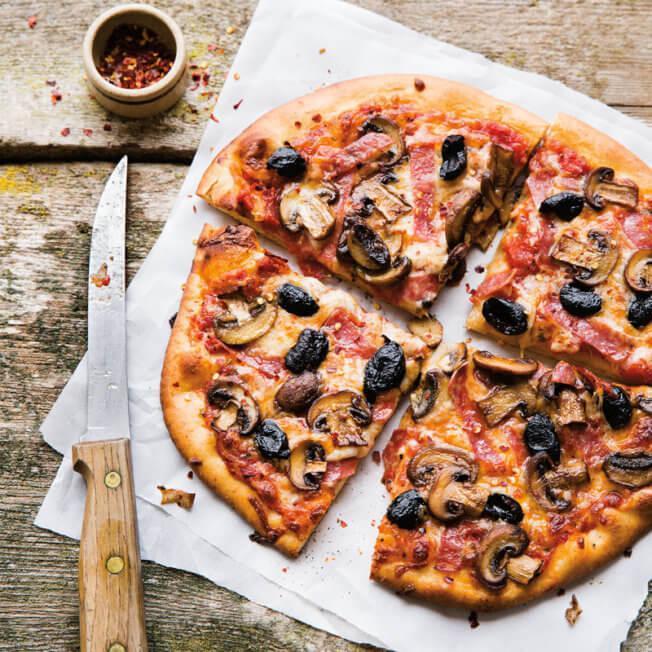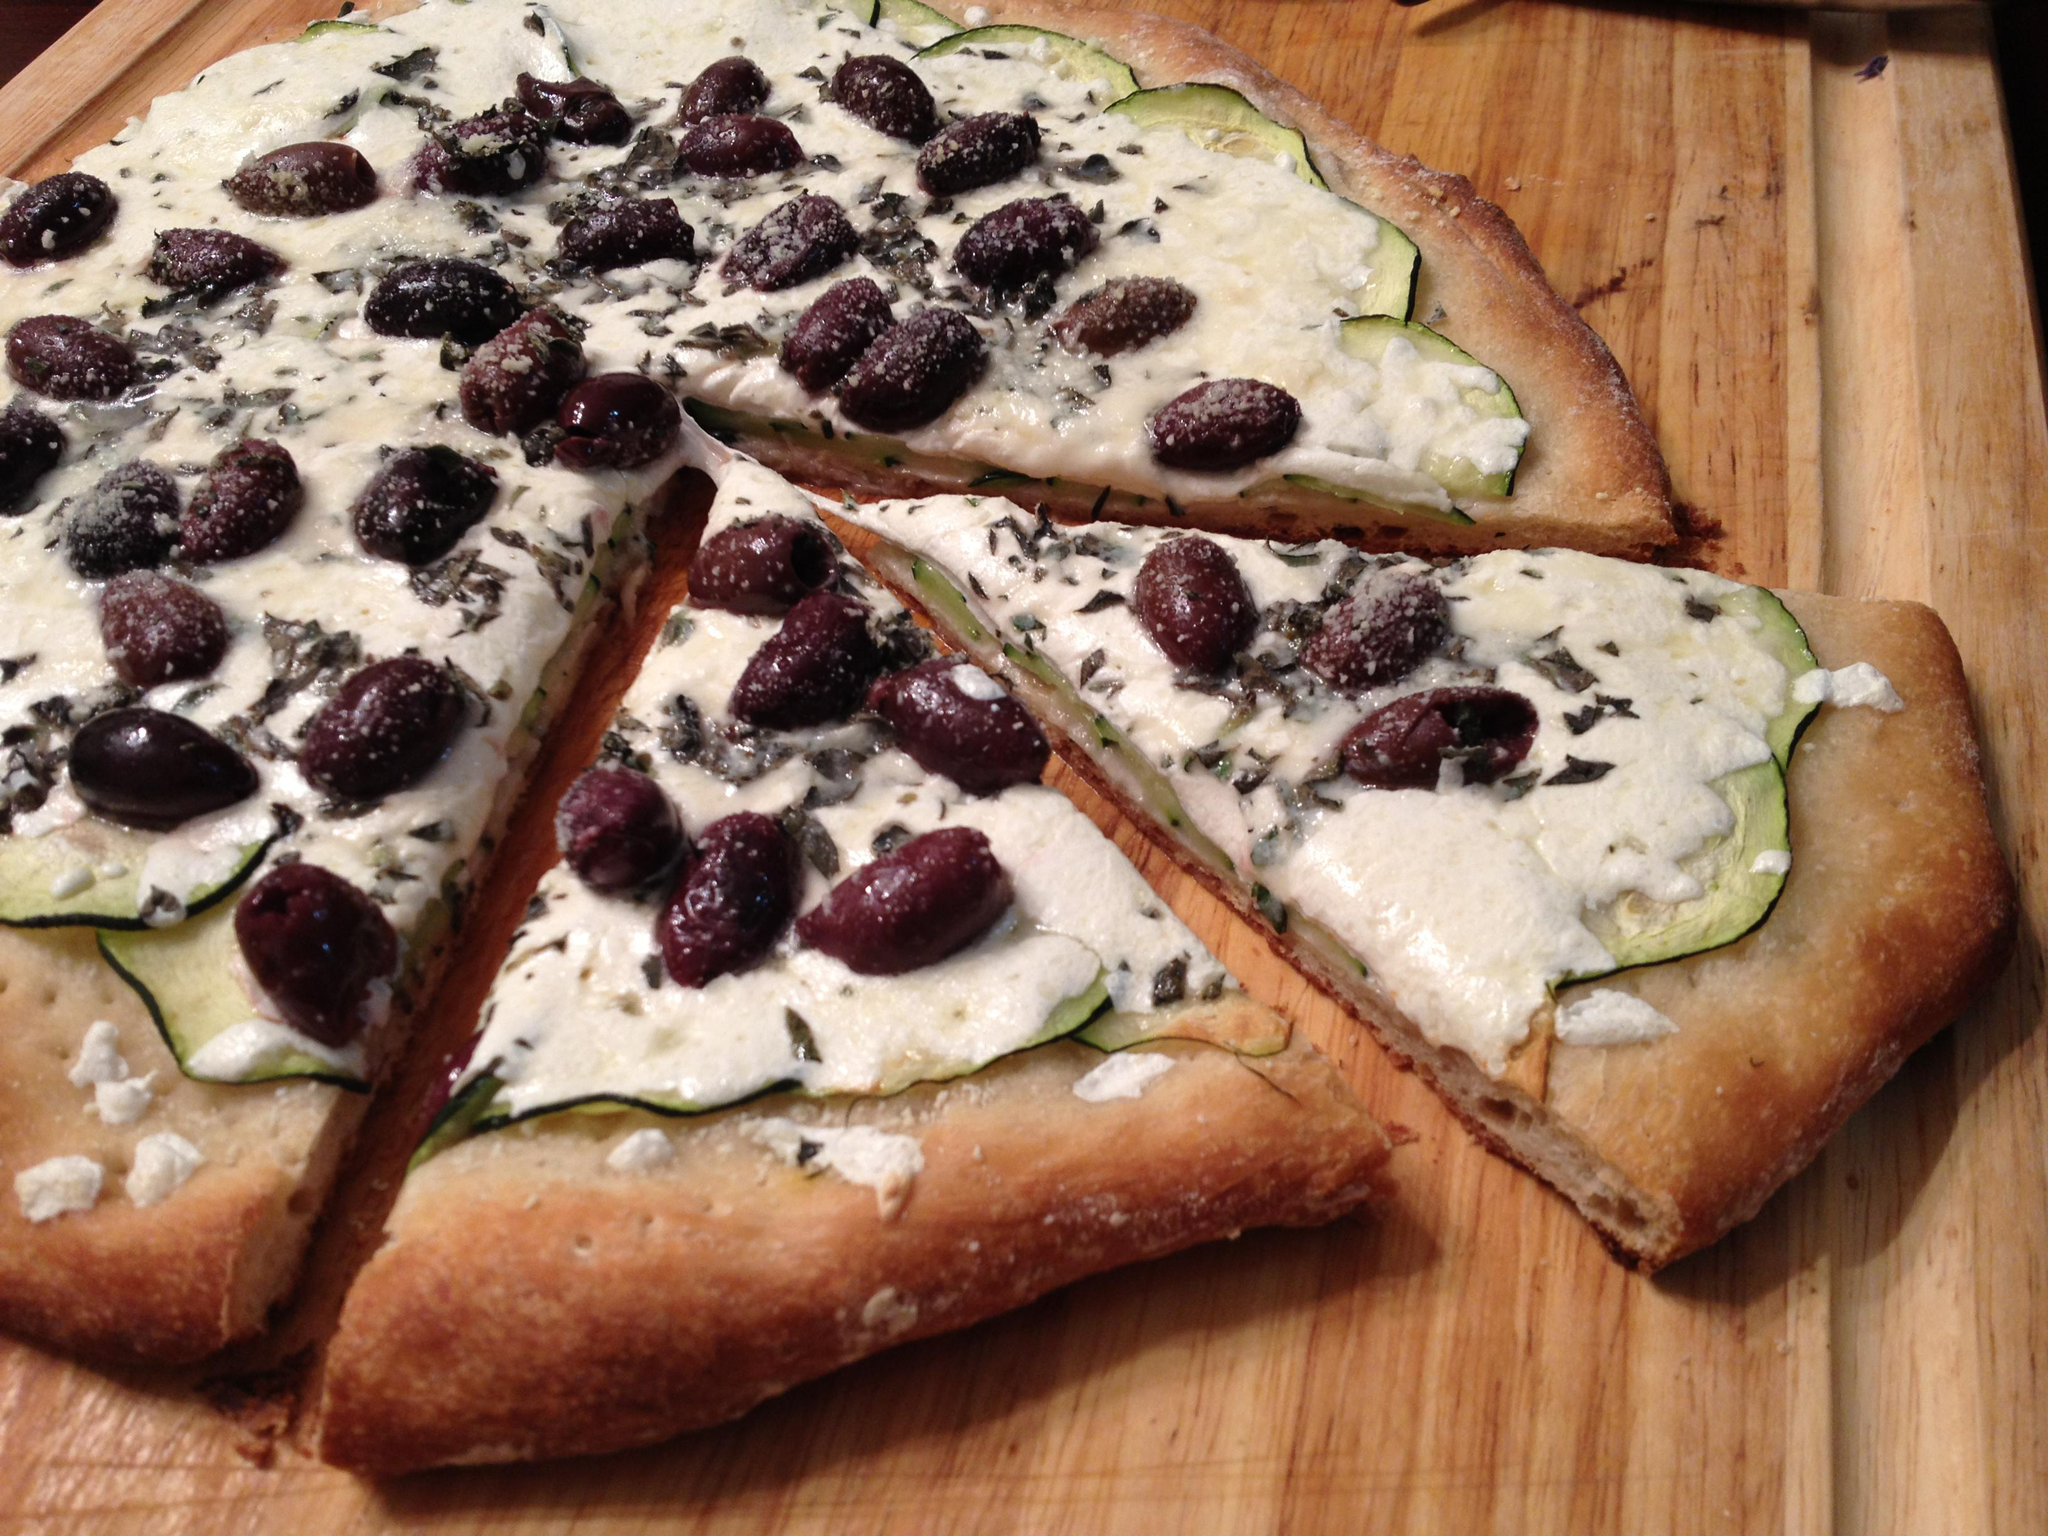The first image is the image on the left, the second image is the image on the right. Given the left and right images, does the statement "One or more pizzas contain pepperoni." hold true? Answer yes or no. No. The first image is the image on the left, the second image is the image on the right. Analyze the images presented: Is the assertion "There are two circle pizzas uncut or all of it's slices are touching." valid? Answer yes or no. No. 